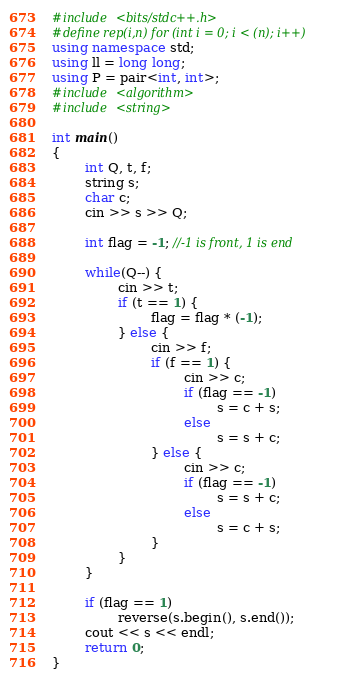Convert code to text. <code><loc_0><loc_0><loc_500><loc_500><_C++_>#include <bits/stdc++.h>
#define rep(i,n) for (int i = 0; i < (n); i++)
using namespace std;
using ll = long long;
using P = pair<int, int>;
#include <algorithm>
#include <string>

int main()
{
        int Q, t, f;
        string s;
        char c;
        cin >> s >> Q;

        int flag = -1; //-1 is front, 1 is end

        while(Q--) {
                cin >> t;
                if (t == 1) {
                        flag = flag * (-1);
                } else {
                        cin >> f;
                        if (f == 1) {
                                cin >> c;
                                if (flag == -1)
                                        s = c + s;
                                else 
                                        s = s + c;
                        } else {
                                cin >> c;
                                if (flag == -1)
                                        s = s + c;
                                else 
                                        s = c + s;
                        }
                }
        }

        if (flag == 1)
                reverse(s.begin(), s.end());
        cout << s << endl;
        return 0;
}
</code> 